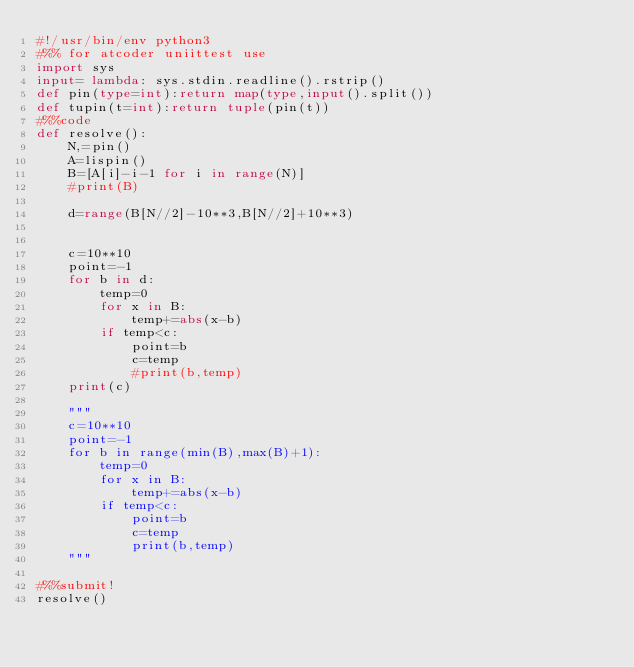<code> <loc_0><loc_0><loc_500><loc_500><_Python_>#!/usr/bin/env python3
#%% for atcoder uniittest use
import sys
input= lambda: sys.stdin.readline().rstrip()
def pin(type=int):return map(type,input().split())
def tupin(t=int):return tuple(pin(t))
#%%code
def resolve():
    N,=pin()
    A=lispin()
    B=[A[i]-i-1 for i in range(N)]
    #print(B)
    
    d=range(B[N//2]-10**3,B[N//2]+10**3)

    
    c=10**10
    point=-1
    for b in d:
        temp=0
        for x in B:
            temp+=abs(x-b)
        if temp<c:
            point=b
            c=temp
            #print(b,temp)
    print(c)
    
    """
    c=10**10
    point=-1
    for b in range(min(B),max(B)+1):
        temp=0
        for x in B:
            temp+=abs(x-b)
        if temp<c:
            point=b
            c=temp
            print(b,temp)
    """
    
#%%submit!
resolve()</code> 